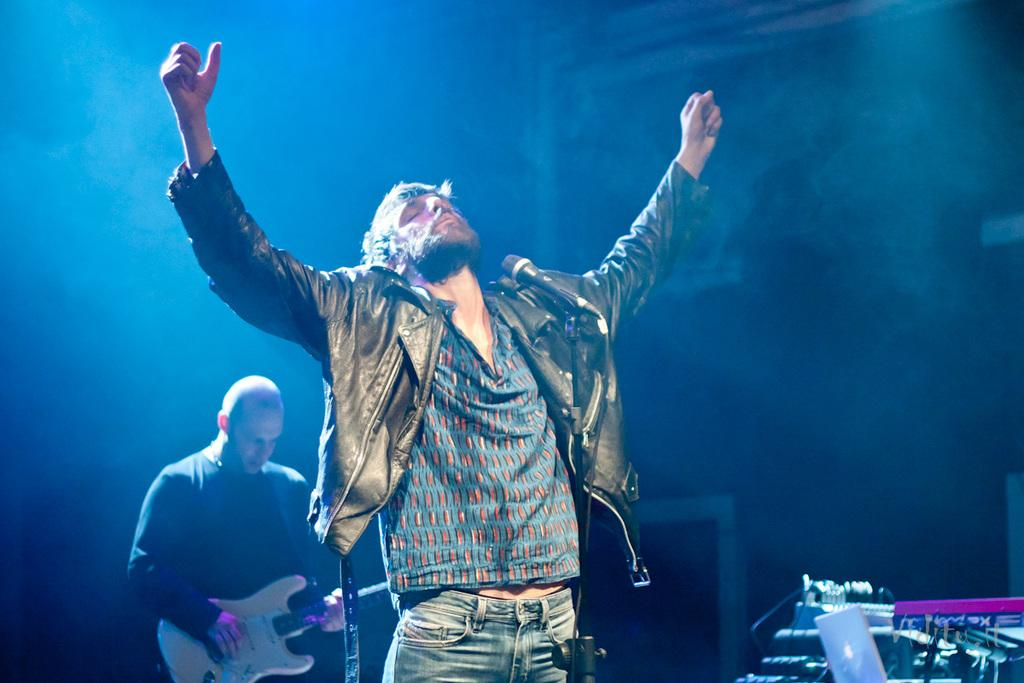What is the man in the black jacket doing in the image? The man in the black jacket is standing in front of a microphone. What is the second man doing in the image? The second man is standing and playing a guitar. Can you describe the clothing of the man in the microphone? The man in the black jacket is wearing a black jacket. Are there any bears experiencing pleasure in the image? There are no bears present in the image, so it is not possible to determine if they are experiencing pleasure. 